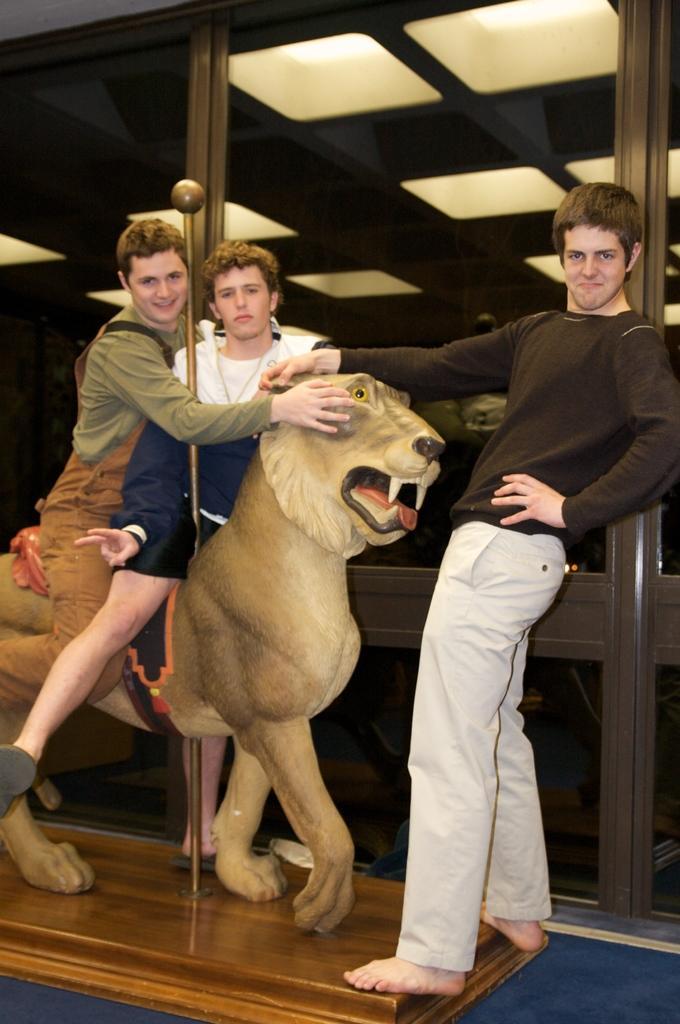Describe this image in one or two sentences. In the center of this picture we can see the two persons sitting on the sculpture of an animal. On the right there is a person wearing black color t-shirt and standing. In the background we can see the roof, ceiling lights and some other objects, we can see the metal rod. 